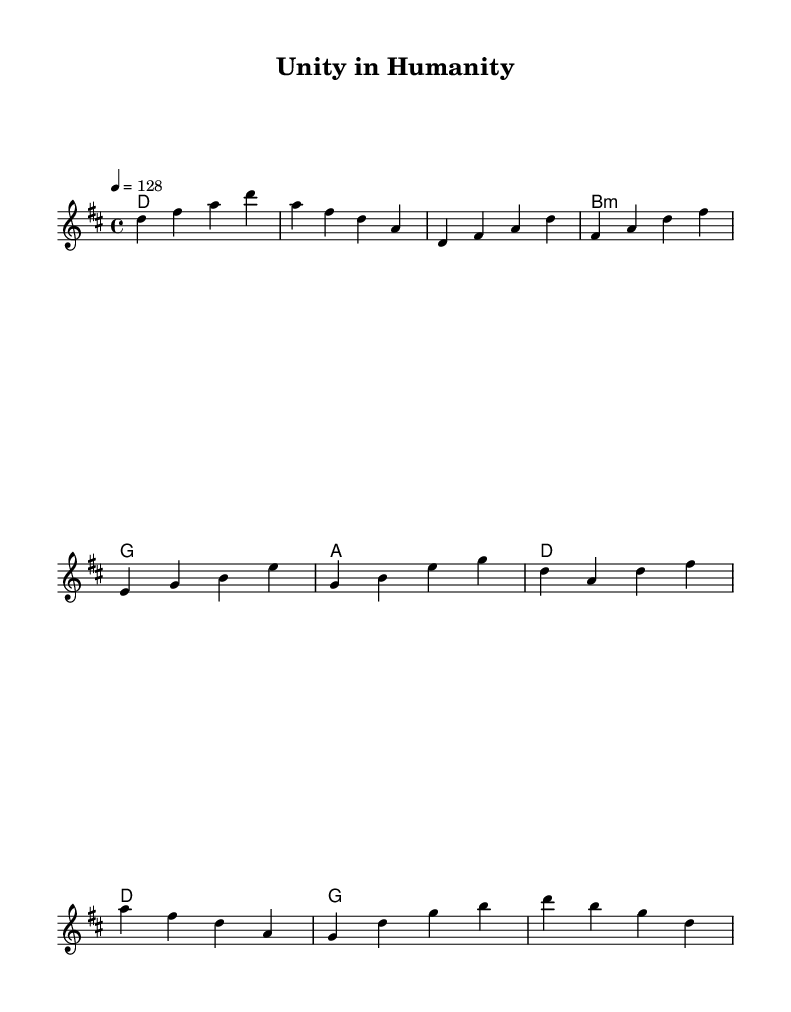What is the key signature of this music? The key signature indicated in the music sheet shows that the piece is in D major, which has two sharps (F# and C#).
Answer: D major What is the time signature of this music? The time signature is found at the beginning of the score and is noted as 4/4, meaning there are four beats in each measure and a quarter note gets one beat.
Answer: 4/4 What is the tempo marking of this piece? The tempo marking shows that the piece should be played at 128 beats per minute, as indicated by the tempo text "4 = 128".
Answer: 128 How many measures are there in the chorus? By counting the measures indicated in the chorus section from the provided music, we find there are four measures.
Answer: 4 What is the final note of the melody in the score? The final note in the melody, indicated by the last note in the sequence, is a D, which is also the root note of the key signature.
Answer: D In which section does the melody first use the note A? The melody first uses the note A in the verse section, as the notes listed include A for the first time in that part.
Answer: Verse How many unique chords are presented in the harmonies section? By analyzing the chord progression in the harmonies, we observe that there are five unique chords: D, B minor, G, and A, counting the D chords collectively.
Answer: 4 